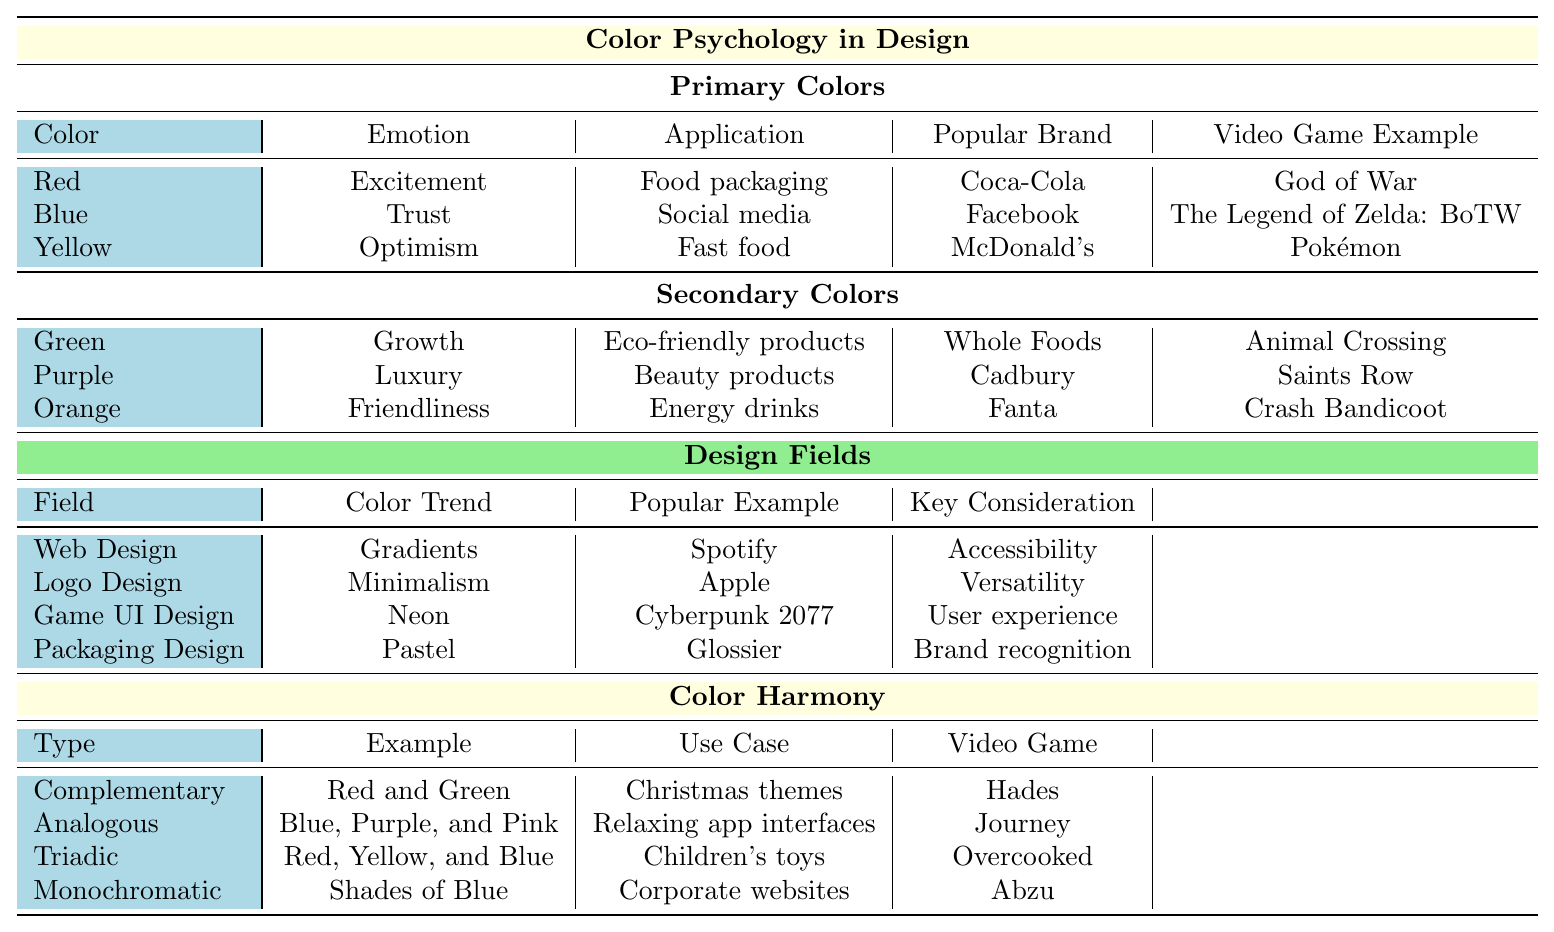What emotion is associated with the color blue? The table specifies that blue is associated with the emotion of trust.
Answer: Trust Which primary color is linked to fast food? According to the table, yellow is the primary color linked to fast food, specifically with the application of McDonald's branding.
Answer: Yellow What key consideration is highlighted in Game UI Design? The table indicates that user experience is the key consideration for Game UI Design.
Answer: User experience Which video game example uses the color red? The table lists "God of War" as the video game example that uses the color red, which is associated with excitement.
Answer: God of War Are gradients a color trend in web design? Yes, the table confirms that gradients are indeed a color trend in web design.
Answer: Yes What is the popular brand associated with eco-friendly products? According to the table, Whole Foods is the popular brand associated with eco-friendly products, which relates to the secondary color green.
Answer: Whole Foods Which design field uses pastel colors, and what is its popular product? The table shows that packaging design uses pastel colors, and the popular product associated with it is Glossier.
Answer: Glossier Which color harmony is associated with the example of "Christmas themes"? The complementary color harmony, specifically red and green, is associated with Christmas themes as per the table.
Answer: Complementary How many video game examples are mentioned for secondary colors? There are three video game examples mentioned for secondary colors: Animal Crossing for green, Saints Row for purple, and Crash Bandicoot for orange, totaling three examples.
Answer: 3 If we look at the applications of the primary colors, which one is linked to social media? The color blue is linked to social media, specifically with the brand Facebook, as outlined in the table.
Answer: Blue 